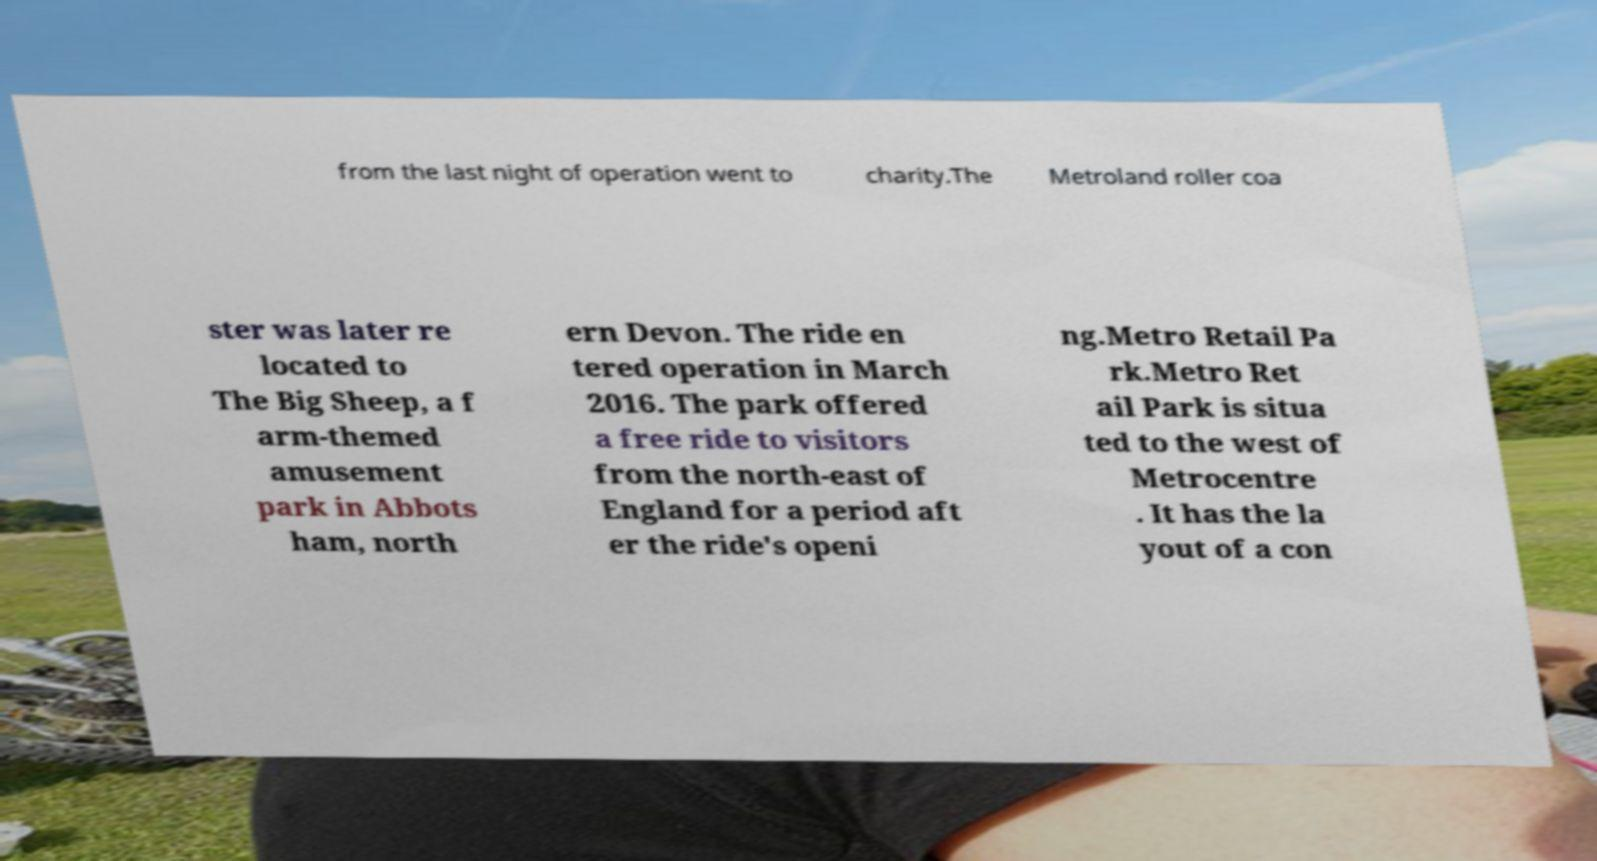Can you accurately transcribe the text from the provided image for me? from the last night of operation went to charity.The Metroland roller coa ster was later re located to The Big Sheep, a f arm-themed amusement park in Abbots ham, north ern Devon. The ride en tered operation in March 2016. The park offered a free ride to visitors from the north-east of England for a period aft er the ride's openi ng.Metro Retail Pa rk.Metro Ret ail Park is situa ted to the west of Metrocentre . It has the la yout of a con 